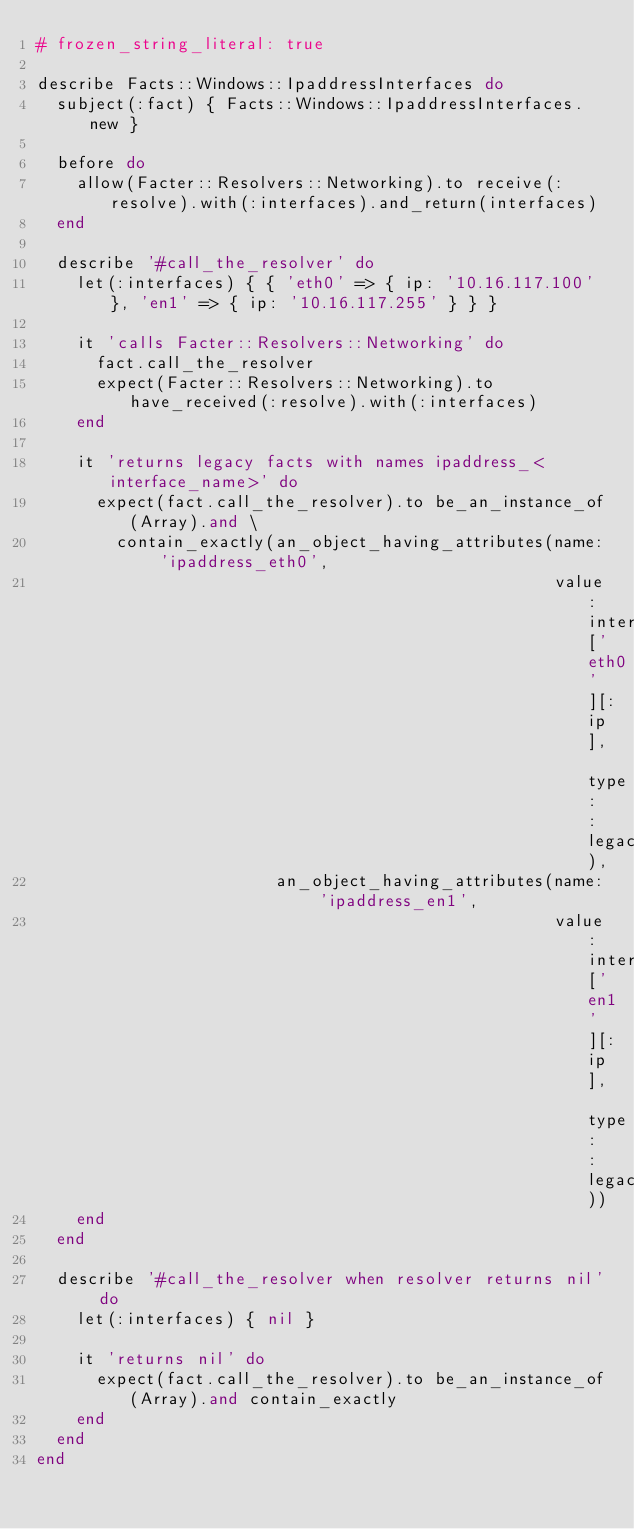Convert code to text. <code><loc_0><loc_0><loc_500><loc_500><_Ruby_># frozen_string_literal: true

describe Facts::Windows::IpaddressInterfaces do
  subject(:fact) { Facts::Windows::IpaddressInterfaces.new }

  before do
    allow(Facter::Resolvers::Networking).to receive(:resolve).with(:interfaces).and_return(interfaces)
  end

  describe '#call_the_resolver' do
    let(:interfaces) { { 'eth0' => { ip: '10.16.117.100' }, 'en1' => { ip: '10.16.117.255' } } }

    it 'calls Facter::Resolvers::Networking' do
      fact.call_the_resolver
      expect(Facter::Resolvers::Networking).to have_received(:resolve).with(:interfaces)
    end

    it 'returns legacy facts with names ipaddress_<interface_name>' do
      expect(fact.call_the_resolver).to be_an_instance_of(Array).and \
        contain_exactly(an_object_having_attributes(name: 'ipaddress_eth0',
                                                    value: interfaces['eth0'][:ip], type: :legacy),
                        an_object_having_attributes(name: 'ipaddress_en1',
                                                    value: interfaces['en1'][:ip], type: :legacy))
    end
  end

  describe '#call_the_resolver when resolver returns nil' do
    let(:interfaces) { nil }

    it 'returns nil' do
      expect(fact.call_the_resolver).to be_an_instance_of(Array).and contain_exactly
    end
  end
end
</code> 